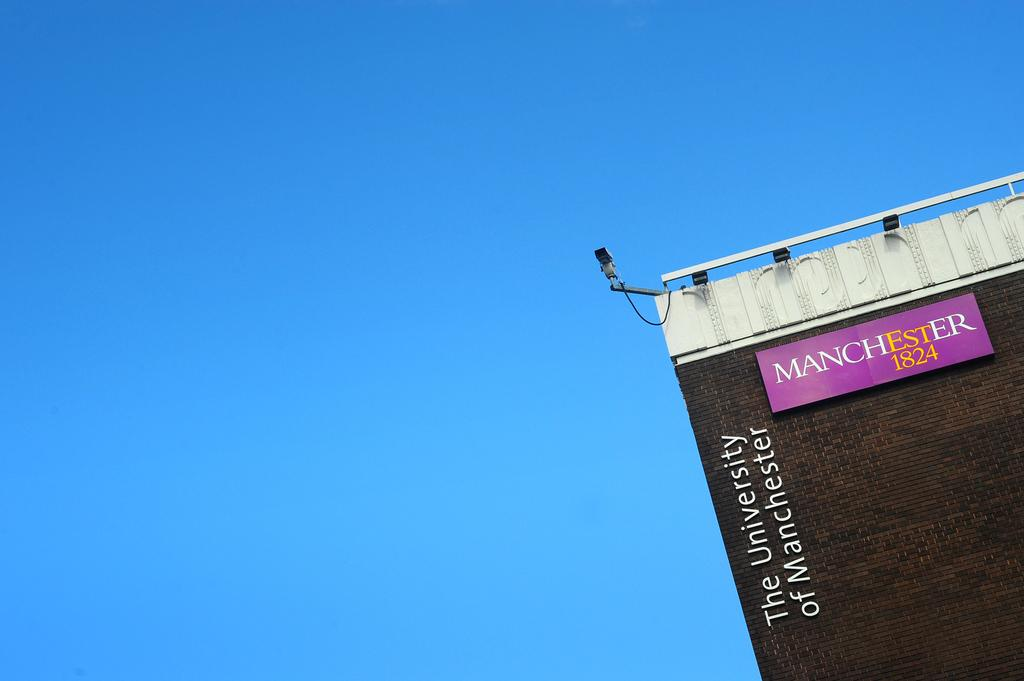<image>
Describe the image concisely. a building with the university of manchester on the side 